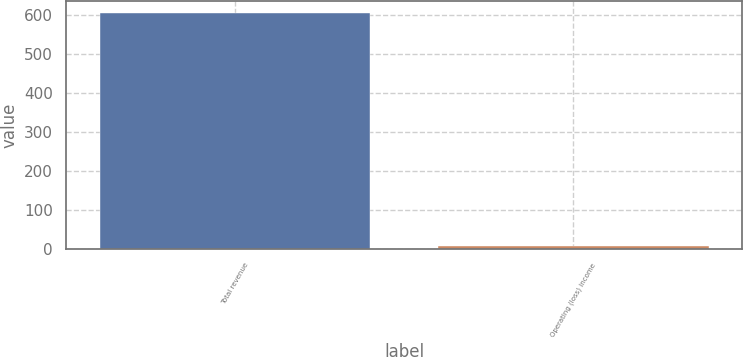Convert chart. <chart><loc_0><loc_0><loc_500><loc_500><bar_chart><fcel>Total revenue<fcel>Operating (loss) income<nl><fcel>606<fcel>8<nl></chart> 